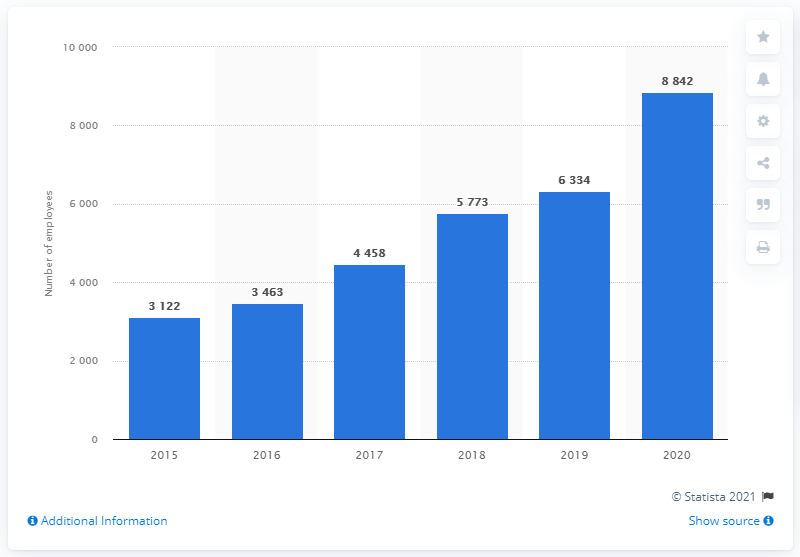List a handful of essential elements in this visual. By the end of 2019, the Mail.ru Group had a total of 8,842 full-time employees. 